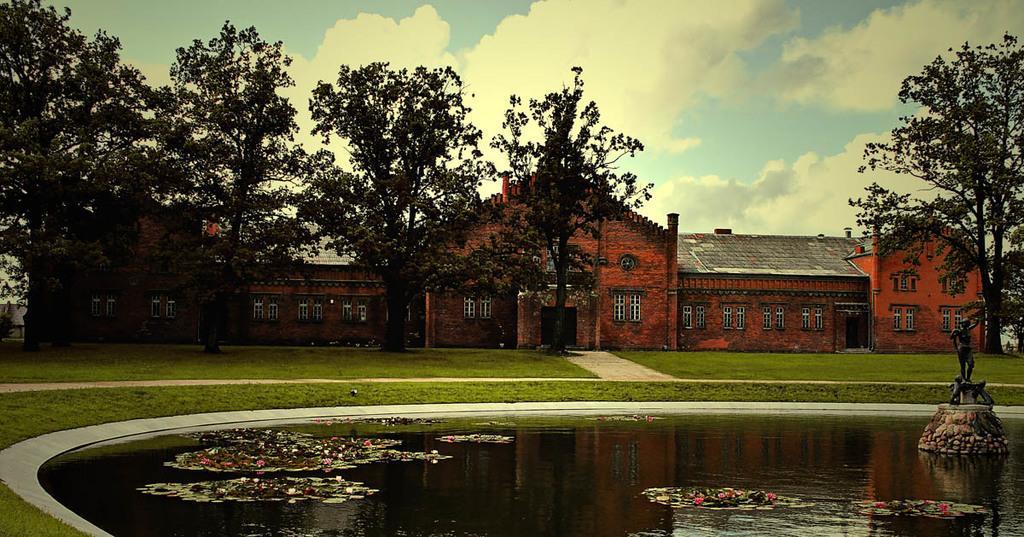Please provide a concise description of this image. In this image on the foreground on the water body there are flowers, and a statue is here on the right. In the background there are trees, buildings. This is the path. The sky is cloudy. 